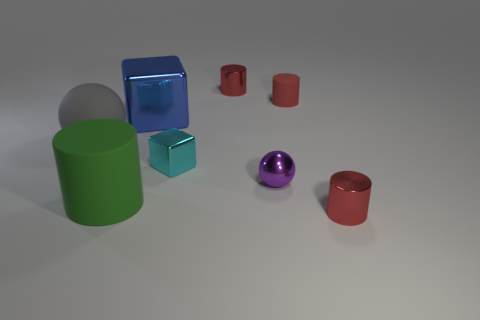There is a object that is both to the left of the cyan metallic thing and in front of the big matte sphere; how big is it?
Keep it short and to the point. Large. How many other small metallic things are the same shape as the blue thing?
Your answer should be very brief. 1. What material is the cyan block?
Give a very brief answer. Metal. Is the shape of the blue shiny object the same as the green thing?
Provide a short and direct response. No. Are there any small red cubes made of the same material as the big blue thing?
Make the answer very short. No. There is a large object that is both behind the cyan metal block and in front of the big block; what is its color?
Offer a terse response. Gray. What is the red cylinder that is in front of the blue metal object made of?
Offer a very short reply. Metal. Is there a tiny red metal object that has the same shape as the large metal thing?
Give a very brief answer. No. What number of other things are there of the same shape as the green rubber object?
Keep it short and to the point. 3. There is a large gray object; is its shape the same as the large thing in front of the purple thing?
Your answer should be very brief. No. 